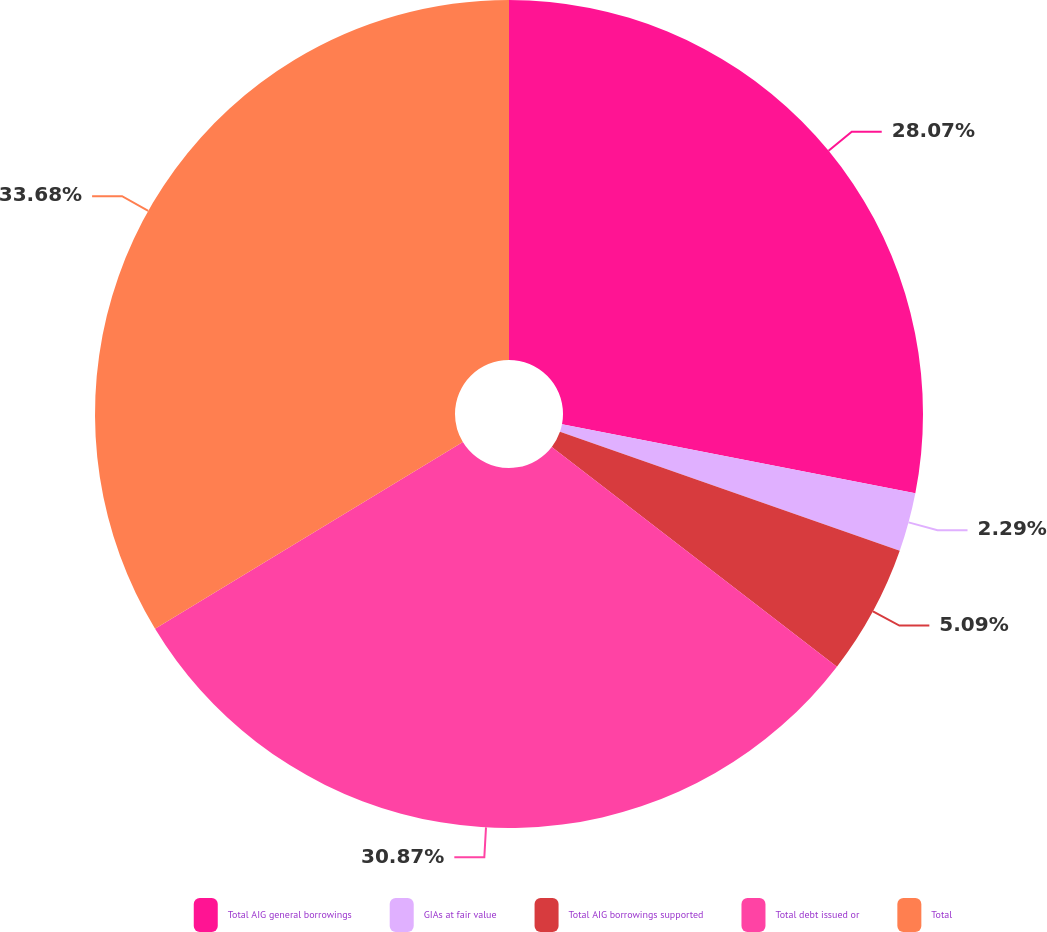Convert chart to OTSL. <chart><loc_0><loc_0><loc_500><loc_500><pie_chart><fcel>Total AIG general borrowings<fcel>GIAs at fair value<fcel>Total AIG borrowings supported<fcel>Total debt issued or<fcel>Total<nl><fcel>28.07%<fcel>2.29%<fcel>5.09%<fcel>30.87%<fcel>33.68%<nl></chart> 